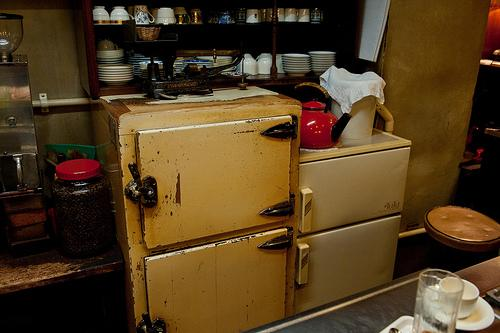Mention the items present on the counter in the image. On the counter, there is a jar, a glass, an empty glass, a clear drinking grass, a cup and saucer, and a tall clear water glass. Can you identify the type of pot situated on top of a fridge in the image? The pot situated on top of a fridge is a red teapot. What style and color is the seating furniture found in this kitchen? The seating furniture in the kitchen is a round brown vinyl stool. What is the color of the antique-looking fridge in the kitchen? The color of the antique-looking fridge in the kitchen is tan. Explain the condition of the refrigerator in the image. The refrigerator in the image is short, yellow, rusted, and dilapidated. What do you think is the primary theme or context of this image? The primary theme or context of this image is an old-fashioned kitchen featuring various pieces of kitchenware and a vintage refrigerator. What interesting objects do you see on the shelf? On the shelf, there are dishes, a stack of white plates, white bowels, and two shelves full of cups and dishes. Which objects in the image have a red color? The objects with a red color are a teapot, jar lid, tea kettle, and a jar with a red lid. Describe the sentiment or atmosphere in this kitchen setting. The atmosphere in this kitchen setting is vintage, with a rustic charm due to features like the antique fridge and various kitchenware items. Can you identify any unusual items or anomalies in the image? There is a container with a small towel over it and a white pipe on the wall which might be considered as unusual items. Create a short story that takes place in this kitchen scene. Once upon a time in a cozy kitchen, the red teapot happily whistled while heating water for tea. The vintage yellow ice box hummed, keeping the ingredients fresh. The shelves held steaming cups and dishes, awaiting delicious pastries from the oven. Provide a brief description of the jar and its contents. It's a jar with a red lid, full of beans, and located on the counter. Could you show me a yellow teakettle on the stovetop X:291 Y:80 Width:60 Height:60? The instruction mentions a yellow teakettle on the stovetop, while the image shows a red tea kettle with the given coordinates. Explain the layout of the shelving system in the image. There are two shelves full of cups and dishes, with teacups in a cupboard, stacks of white plates and white bowls. In the image, identify an object that holds dishes and comment on its position. A shelf holds dishes, and it is on the upper part of the image. Can you find the green teapot on the floor X:277 Y:83 Width:89 Height:89? The instruction mentions a green teapot on the floor, while the image contains a red teapot on a fridge with the given coordinates. What color is the refrigerator in the kitchen? Tan Describe the appearance of the drinking glass in the image. It's a tall, clear water glass with no visible liquid inside. Could you point to the stack of black plates on the table X:96 Y:59 Width:39 Height:39? The instruction mentions a stack of black plates on the table, while the image shows a stack of white plates with the given coordinates. Describe one pair of related objects in the image. There is a tea cup on a saucer, both white and placed on the counter. In the image, explain what the jar with the red lid is resting on. The jar with the red lid is resting on the counter. Is the blue refrigerator in the living room X:120 Y:117 Width:191 Height:191? The instruction mentions a blue refrigerator, while the image shows a tan fridge in a kitchen with the given coordinates. Read the letters or numbers printed on any object in the image. No OCR information is present in the image. Create a haiku inspired by the kitchen scene in the image. Vintage kitchen hums, What activity or event is taking place in the image? No specific activity or event is taking place; it's a still image of a kitchen scene. Select and describe an object that is not commonly found in a kitchen. A round, brown vinyl stool is present in the image, which is not typically found in a kitchen. Does the image show a teapot on top of the fridge? If so, what color is it? Yes, red Describe the appearance of the refrigerator in the image. It's a vintage yellow ice box with rust on the metal parts and a black hinge on the door. Are there any objects with numbers or letters visible in the image? State yes or no. No Where is the purple wall in the bathroom X:383 Y:41 Width:114 Height:114? The instruction mentions a purple wall in the bathroom, while the image shows a gray wall in the kitchen with the given coordinates. Do you see a full glass of orange juice on the counter X:406 Y:271 Width:56 Height:56? The instruction mentions a full glass of orange juice, while the image contains a clear empty glass on the counter with the given coordinates. Which kitchen appliances are present in the image? List them. Refrigerator, red teapot 